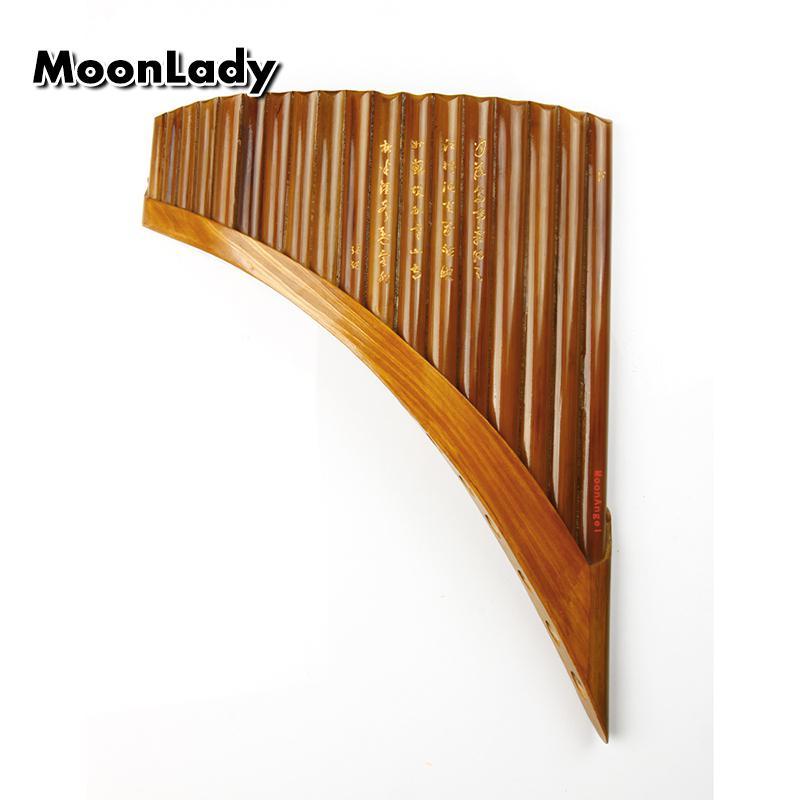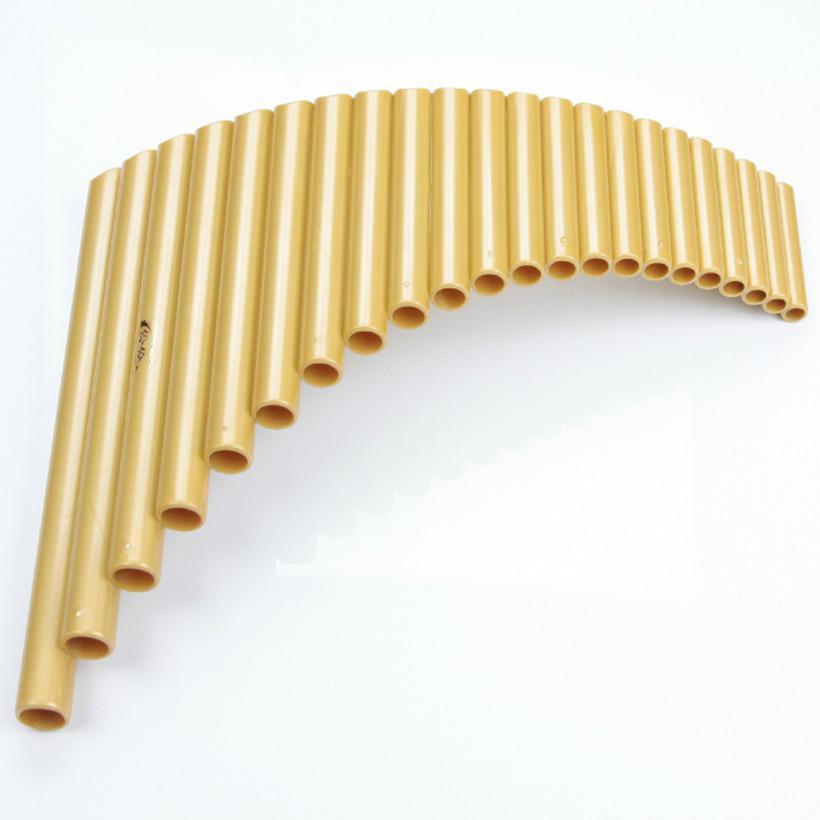The first image is the image on the left, the second image is the image on the right. Analyze the images presented: Is the assertion "Each instrument is curved." valid? Answer yes or no. Yes. The first image is the image on the left, the second image is the image on the right. Analyze the images presented: Is the assertion "Each image shows an instrument displayed with its aligned ends at the top, and its tallest 'tube' at the left." valid? Answer yes or no. No. 